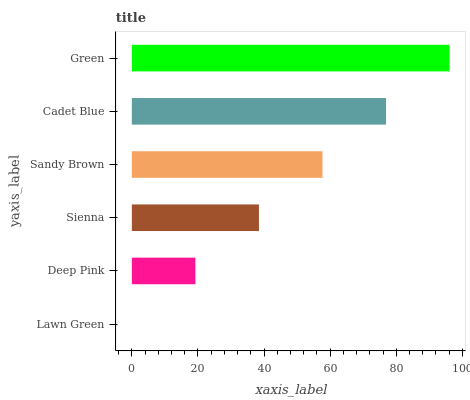Is Lawn Green the minimum?
Answer yes or no. Yes. Is Green the maximum?
Answer yes or no. Yes. Is Deep Pink the minimum?
Answer yes or no. No. Is Deep Pink the maximum?
Answer yes or no. No. Is Deep Pink greater than Lawn Green?
Answer yes or no. Yes. Is Lawn Green less than Deep Pink?
Answer yes or no. Yes. Is Lawn Green greater than Deep Pink?
Answer yes or no. No. Is Deep Pink less than Lawn Green?
Answer yes or no. No. Is Sandy Brown the high median?
Answer yes or no. Yes. Is Sienna the low median?
Answer yes or no. Yes. Is Lawn Green the high median?
Answer yes or no. No. Is Green the low median?
Answer yes or no. No. 